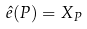Convert formula to latex. <formula><loc_0><loc_0><loc_500><loc_500>\hat { e } ( P ) = X _ { P }</formula> 